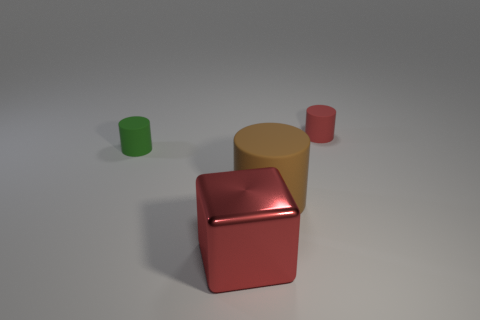There is a green object that is the same material as the small red thing; what is its size?
Ensure brevity in your answer.  Small. How many matte things are either red blocks or red cylinders?
Provide a short and direct response. 1. How big is the green matte thing?
Ensure brevity in your answer.  Small. Is the brown cylinder the same size as the green matte cylinder?
Your answer should be very brief. No. What is the cylinder in front of the green object made of?
Provide a short and direct response. Rubber. There is a red thing that is the same shape as the tiny green rubber object; what is its material?
Offer a terse response. Rubber. There is a small matte cylinder to the left of the large brown cylinder; are there any brown cylinders behind it?
Keep it short and to the point. No. Is the shape of the small red object the same as the tiny green rubber thing?
Keep it short and to the point. Yes. There is a red thing that is made of the same material as the big brown cylinder; what shape is it?
Your answer should be compact. Cylinder. Does the cylinder behind the green matte object have the same size as the cylinder in front of the small green rubber object?
Give a very brief answer. No. 